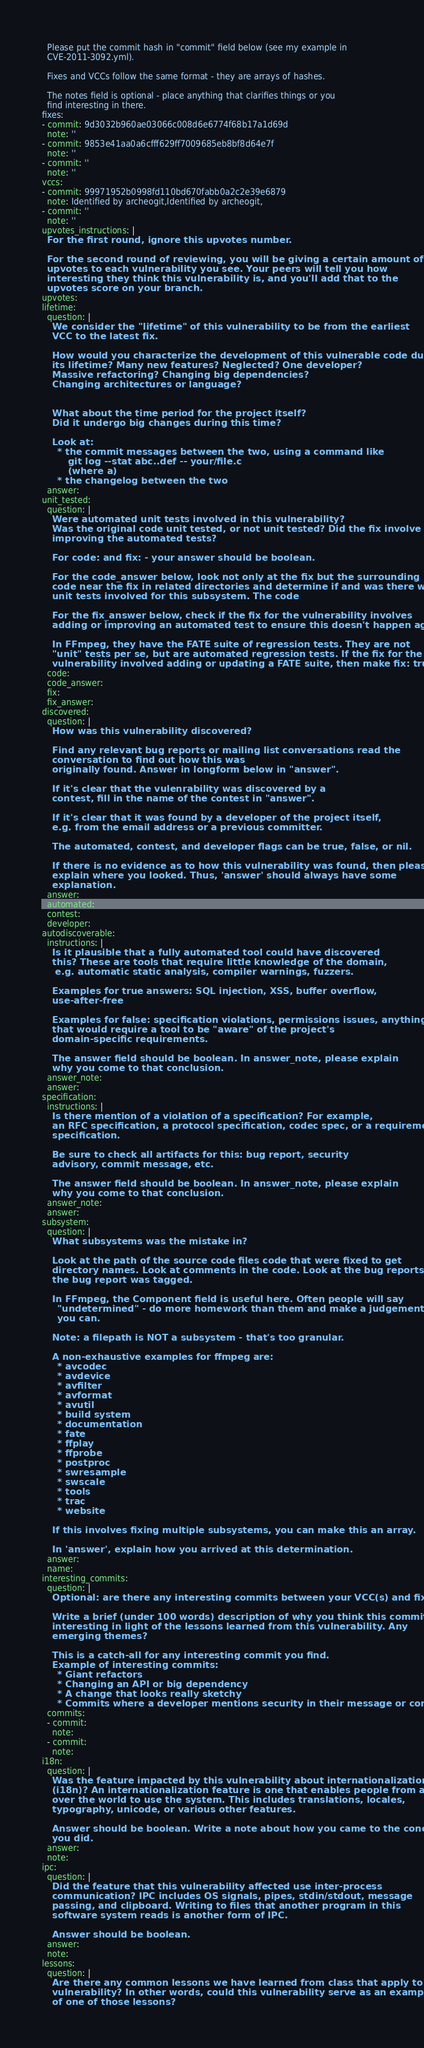<code> <loc_0><loc_0><loc_500><loc_500><_YAML_>  Please put the commit hash in "commit" field below (see my example in
  CVE-2011-3092.yml).

  Fixes and VCCs follow the same format - they are arrays of hashes.

  The notes field is optional - place anything that clarifies things or you
  find interesting in there.
fixes:
- commit: 9d3032b960ae03066c008d6e6774f68b17a1d69d
  note: ''
- commit: 9853e41aa0a6cfff629ff7009685eb8bf8d64e7f
  note: ''
- commit: ''
  note: ''
vccs:
- commit: 99971952b0998fd110bd670fabb0a2c2e39e6879
  note: Identified by archeogit,Identified by archeogit,
- commit: ''
  note: ''
upvotes_instructions: |
  For the first round, ignore this upvotes number.

  For the second round of reviewing, you will be giving a certain amount of
  upvotes to each vulnerability you see. Your peers will tell you how
  interesting they think this vulnerability is, and you'll add that to the
  upvotes score on your branch.
upvotes:
lifetime:
  question: |
    We consider the "lifetime" of this vulnerability to be from the earliest
    VCC to the latest fix.

    How would you characterize the development of this vulnerable code during
    its lifetime? Many new features? Neglected? One developer?
    Massive refactoring? Changing big dependencies?
    Changing architectures or language?


    What about the time period for the project itself?
    Did it undergo big changes during this time?

    Look at:
      * the commit messages between the two, using a command like
          git log --stat abc..def -- your/file.c
          (where a)
      * the changelog between the two
  answer:
unit_tested:
  question: |
    Were automated unit tests involved in this vulnerability?
    Was the original code unit tested, or not unit tested? Did the fix involve
    improving the automated tests?

    For code: and fix: - your answer should be boolean.

    For the code_answer below, look not only at the fix but the surrounding
    code near the fix in related directories and determine if and was there were
    unit tests involved for this subsystem. The code

    For the fix_answer below, check if the fix for the vulnerability involves
    adding or improving an automated test to ensure this doesn't happen again.

    In FFmpeg, they have the FATE suite of regression tests. They are not
    "unit" tests per se, but are automated regression tests. If the fix for the
    vulnerability involved adding or updating a FATE suite, then make fix: true.
  code:
  code_answer:
  fix:
  fix_answer:
discovered:
  question: |
    How was this vulnerability discovered?

    Find any relevant bug reports or mailing list conversations read the
    conversation to find out how this was
    originally found. Answer in longform below in "answer".

    If it's clear that the vulenrability was discovered by a
    contest, fill in the name of the contest in "answer".

    If it's clear that it was found by a developer of the project itself,
    e.g. from the email address or a previous committer.

    The automated, contest, and developer flags can be true, false, or nil.

    If there is no evidence as to how this vulnerability was found, then please
    explain where you looked. Thus, 'answer' should always have some
    explanation.
  answer:
  automated:
  contest:
  developer:
autodiscoverable:
  instructions: |
    Is it plausible that a fully automated tool could have discovered
    this? These are tools that require little knowledge of the domain,
     e.g. automatic static analysis, compiler warnings, fuzzers.

    Examples for true answers: SQL injection, XSS, buffer overflow,
    use-after-free

    Examples for false: specification violations, permissions issues, anything
    that would require a tool to be "aware" of the project's
    domain-specific requirements.

    The answer field should be boolean. In answer_note, please explain
    why you come to that conclusion.
  answer_note:
  answer:
specification:
  instructions: |
    Is there mention of a violation of a specification? For example,
    an RFC specification, a protocol specification, codec spec, or a requirements
    specification.

    Be sure to check all artifacts for this: bug report, security
    advisory, commit message, etc.

    The answer field should be boolean. In answer_note, please explain
    why you come to that conclusion.
  answer_note:
  answer:
subsystem:
  question: |
    What subsystems was the mistake in?

    Look at the path of the source code files code that were fixed to get
    directory names. Look at comments in the code. Look at the bug reports how
    the bug report was tagged.

    In FFmpeg, the Component field is useful here. Often people will say
      "undetermined" - do more homework than them and make a judgement call if
      you can.

    Note: a filepath is NOT a subsystem - that's too granular.

    A non-exhaustive examples for ffmpeg are:
      * avcodec
      * avdevice
      * avfilter
      * avformat
      * avutil
      * build system
      * documentation
      * fate
      * ffplay
      * ffprobe
      * postproc
      * swresample
      * swscale
      * tools
      * trac
      * website

    If this involves fixing multiple subsystems, you can make this an array.

    In 'answer', explain how you arrived at this determination.
  answer:
  name:
interesting_commits:
  question: |
    Optional: are there any interesting commits between your VCC(s) and fix(es)?

    Write a brief (under 100 words) description of why you think this commit was
    interesting in light of the lessons learned from this vulnerability. Any
    emerging themes?

    This is a catch-all for any interesting commit you find.
    Example of interesting commits:
      * Giant refactors
      * Changing an API or big dependency
      * A change that looks really sketchy
      * Commits where a developer mentions security in their message or comments
  commits:
  - commit:
    note:
  - commit:
    note:
i18n:
  question: |
    Was the feature impacted by this vulnerability about internationalization
    (i18n)? An internationalization feature is one that enables people from all
    over the world to use the system. This includes translations, locales,
    typography, unicode, or various other features.

    Answer should be boolean. Write a note about how you came to the conclusions
    you did.
  answer:
  note:
ipc:
  question: |
    Did the feature that this vulnerability affected use inter-process
    communication? IPC includes OS signals, pipes, stdin/stdout, message
    passing, and clipboard. Writing to files that another program in this
    software system reads is another form of IPC.

    Answer should be boolean.
  answer:
  note:
lessons:
  question: |
    Are there any common lessons we have learned from class that apply to this
    vulnerability? In other words, could this vulnerability serve as an example
    of one of those lessons?
</code> 